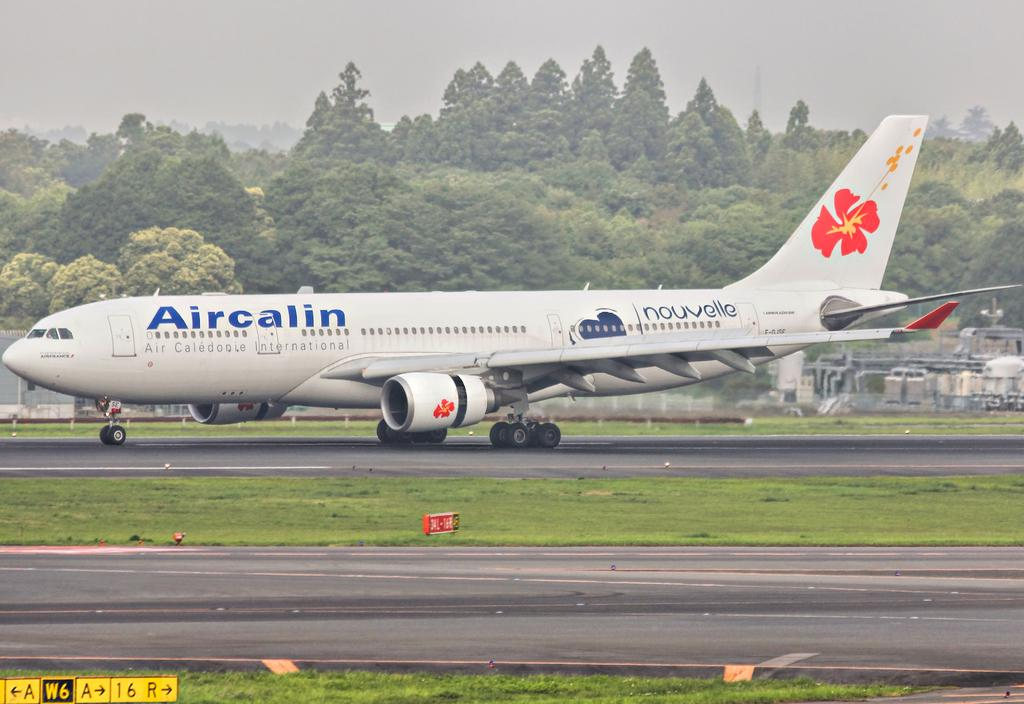<image>
Describe the image concisely. An Aircalin airplane sits parked on the runway at an airport. 